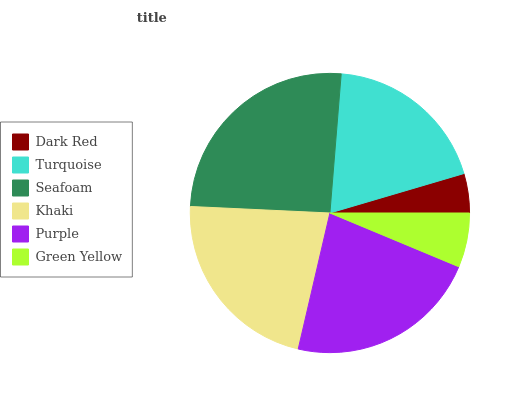Is Dark Red the minimum?
Answer yes or no. Yes. Is Seafoam the maximum?
Answer yes or no. Yes. Is Turquoise the minimum?
Answer yes or no. No. Is Turquoise the maximum?
Answer yes or no. No. Is Turquoise greater than Dark Red?
Answer yes or no. Yes. Is Dark Red less than Turquoise?
Answer yes or no. Yes. Is Dark Red greater than Turquoise?
Answer yes or no. No. Is Turquoise less than Dark Red?
Answer yes or no. No. Is Khaki the high median?
Answer yes or no. Yes. Is Turquoise the low median?
Answer yes or no. Yes. Is Green Yellow the high median?
Answer yes or no. No. Is Khaki the low median?
Answer yes or no. No. 